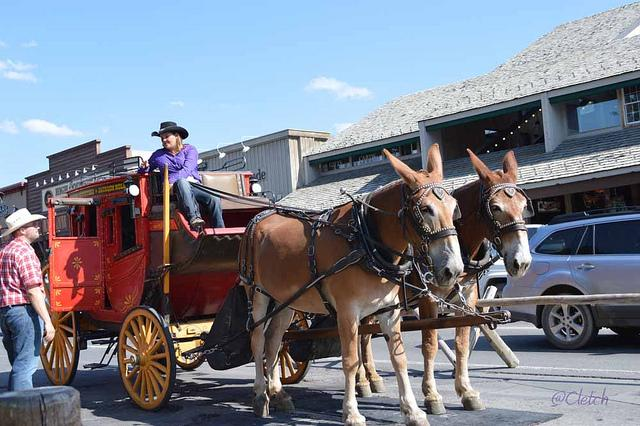What do both of the people have on their heads?

Choices:
A) cowboy hats
B) glasses
C) gas masks
D) helmets cowboy hats 